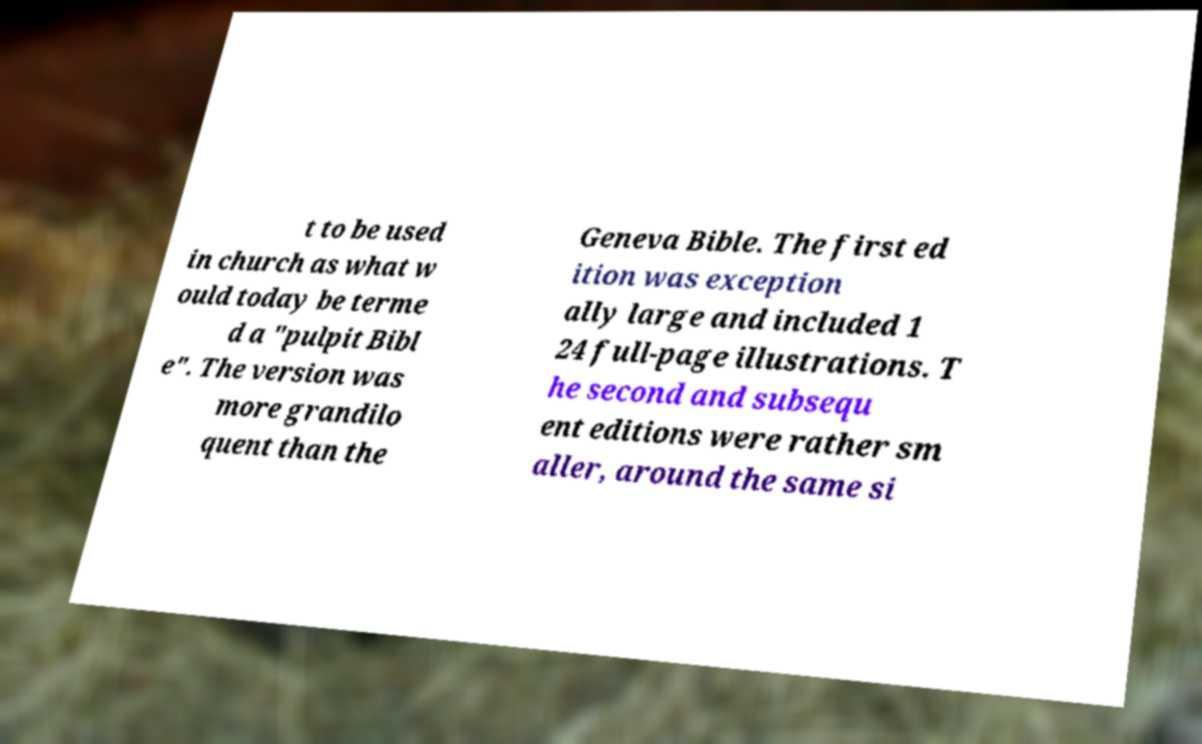Please identify and transcribe the text found in this image. t to be used in church as what w ould today be terme d a "pulpit Bibl e". The version was more grandilo quent than the Geneva Bible. The first ed ition was exception ally large and included 1 24 full-page illustrations. T he second and subsequ ent editions were rather sm aller, around the same si 